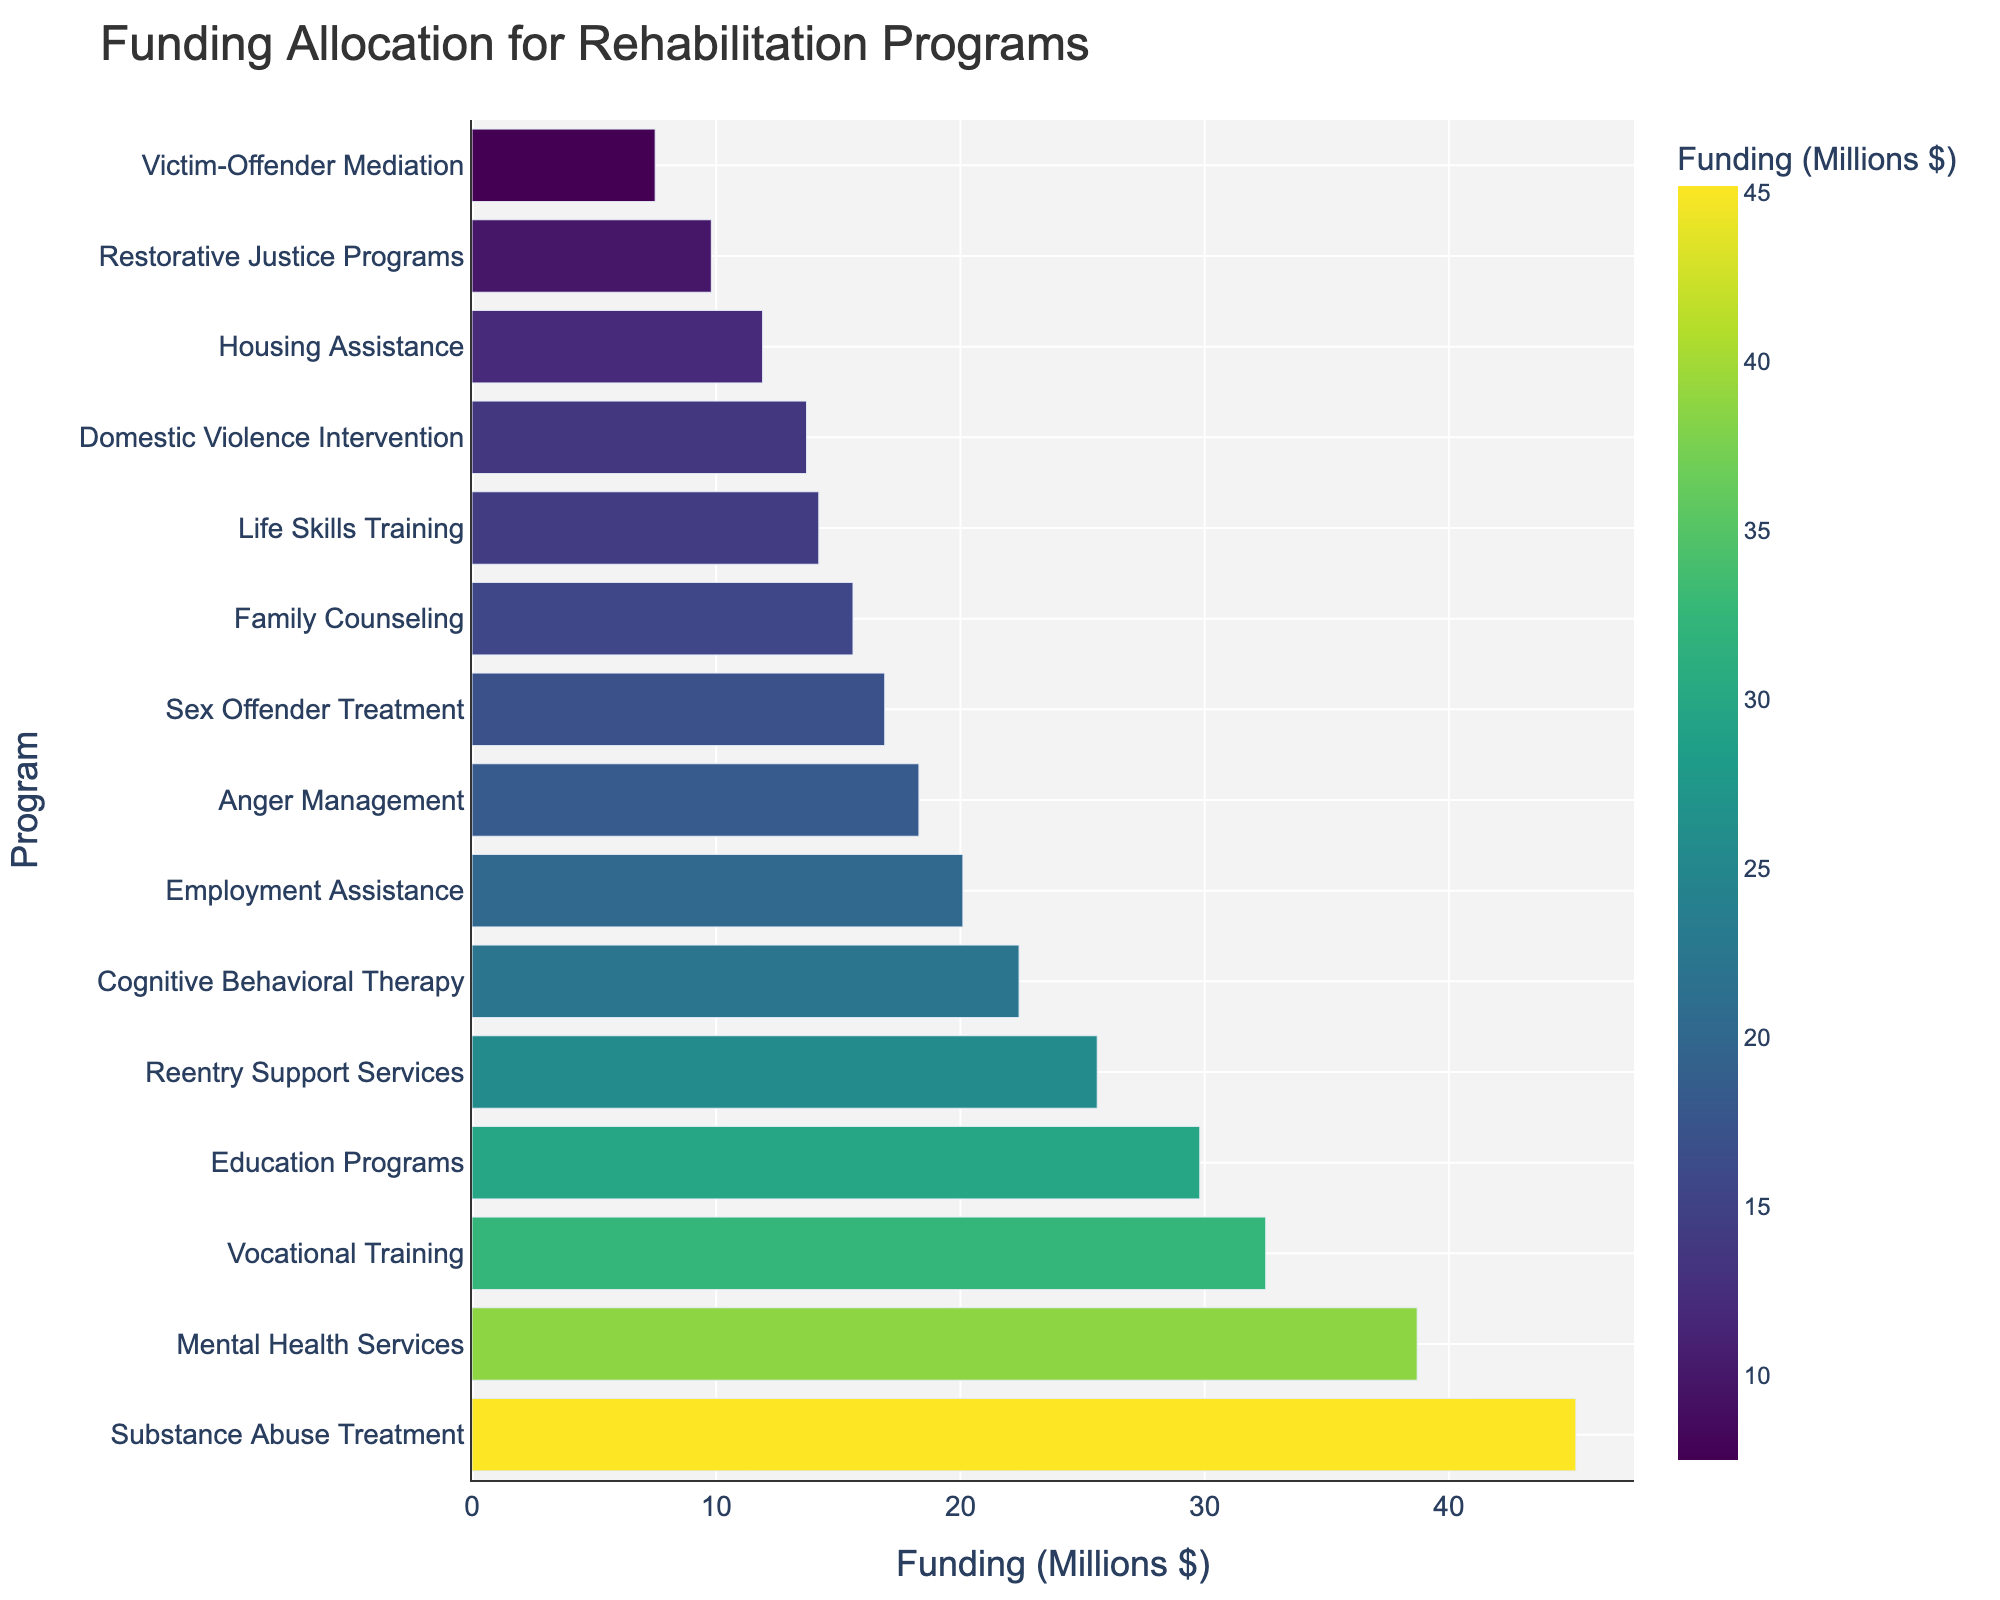What's the highest funded program? The highest funded program can be identified by looking for the bar with the greatest length. In the chart, the longest bar corresponds to "Substance Abuse Treatment" which is at the top with a value of $45.2 million.
Answer: Substance Abuse Treatment Which program receives more funding, Vocational Training or Education Programs? To compare the funding allocations, find the lengths of the bars corresponding to "Vocational Training" and "Education Programs." "Vocational Training" receives $32.5 million, while "Education Programs" receives $29.8 million. Since $32.5 million is greater than $29.8 million, Vocational Training receives more funding.
Answer: Vocational Training What is the total funding allocated to programs related to health (Substance Abuse Treatment, Mental Health Services)? Sum the funding allocations for "Substance Abuse Treatment" ($45.2 million) and "Mental Health Services" ($38.7 million). The combined total is $45.2 million + $38.7 million = $83.9 million.
Answer: $83.9 million How does the funding for Family Counseling compare to that for Housing Assistance? Find the lengths of the bars for "Family Counseling" and "Housing Assistance." "Family Counseling" receives $15.6 million, while "Housing Assistance" receives $11.9 million. Since $15.6 million is greater than $11.9 million, Family Counseling receives more funding.
Answer: Family Counseling What is the average funding allocation for the top three funded programs? Identify the top three funded programs: "Substance Abuse Treatment" ($45.2 million), "Mental Health Services" ($38.7 million), and "Vocational Training" ($32.5 million). To find the average, sum these amounts and divide by 3: ($45.2 million + $38.7 million + $32.5 million) / 3 = $116.4 million / 3 = $38.8 million.
Answer: $38.8 million Which program receives the least funding, and how much is it? The least funded program can be identified by finding the shortest bar on the chart. "Victim-Offender Mediation" is the shortest with a value of $7.5 million.
Answer: Victim-Offender Mediation, $7.5 million Is the funding for Sex Offender Treatment higher or lower than that for Domestic Violence Intervention? Compare the lengths of the bars for "Sex Offender Treatment" and "Domestic Violence Intervention." "Sex Offender Treatment" has $16.9 million, while "Domestic Violence Intervention" has $13.7 million. Since $16.9 million is greater than $13.7 million, Sex Offender Treatment has higher funding.
Answer: Higher What percentage of the total funding is allocated to Anger Management and Family Counseling combined? First, sum the funding for all programs: $341.2 million. Then, find the combined funding for "Anger Management" ($18.3 million) and "Family Counseling" ($15.6 million), which is $18.3 million + $15.6 million = $33.9 million. The percentage is ($33.9 million / $341.2 million) * 100 ≈ 9.94%.
Answer: 9.94% What is the difference in funding between Employment Assistance and Cognitive Behavioral Therapy? Find the funding allocations: "Employment Assistance" is $20.1 million and "Cognitive Behavioral Therapy" is $22.4 million. The difference is $22.4 million - $20.1 million = $2.3 million.
Answer: $2.3 million 